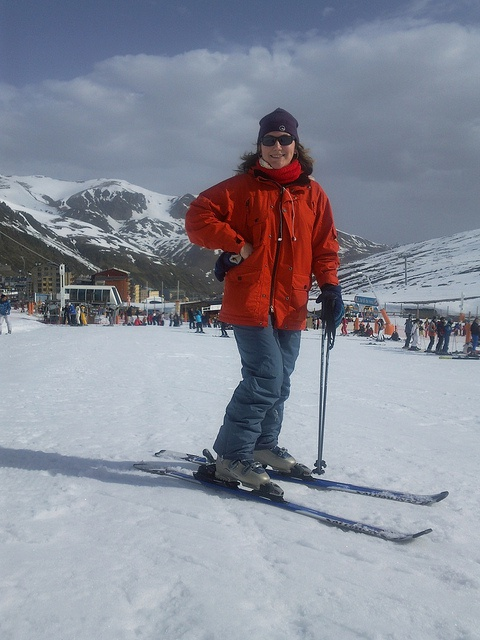Describe the objects in this image and their specific colors. I can see people in gray, maroon, brown, black, and navy tones, skis in gray, darkgray, and navy tones, people in gray, darkgray, and black tones, bus in gray, black, darkgray, and darkblue tones, and people in gray, black, and darkblue tones in this image. 